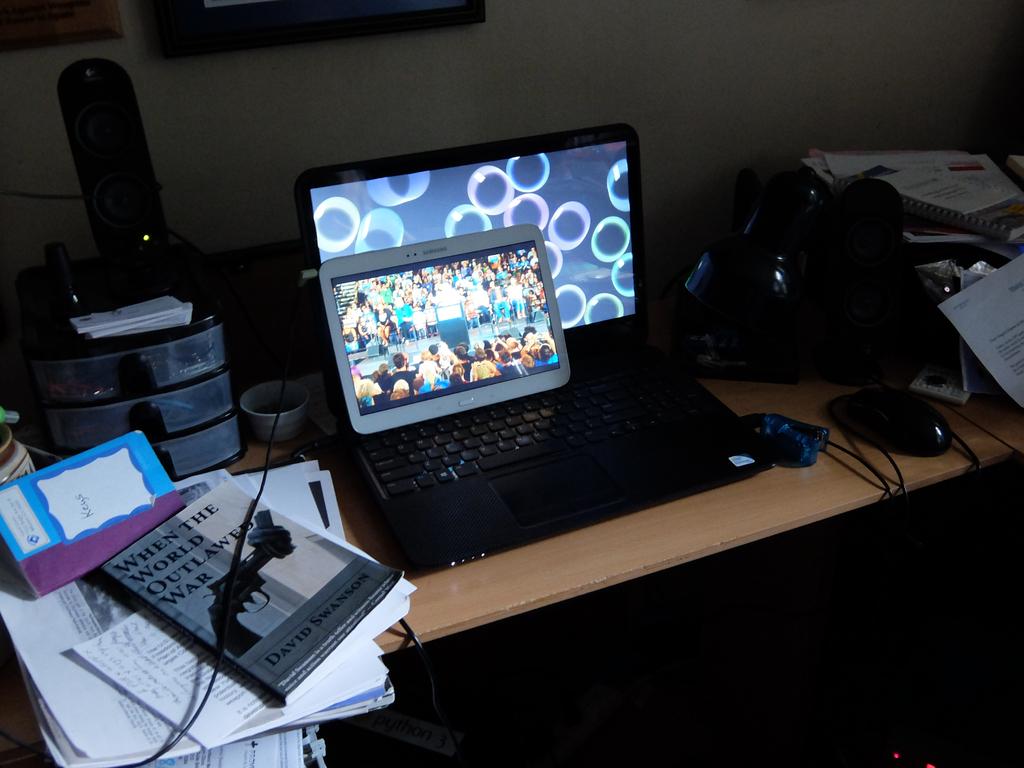What book is next to the laptop?
Your response must be concise. When the world outlawed war. What is the first letter on the book?
Ensure brevity in your answer.  W. 